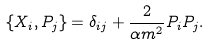Convert formula to latex. <formula><loc_0><loc_0><loc_500><loc_500>\{ X _ { i } , P _ { j } \} = \delta _ { i j } + \frac { 2 } { \alpha m ^ { 2 } } P _ { i } P _ { j } .</formula> 